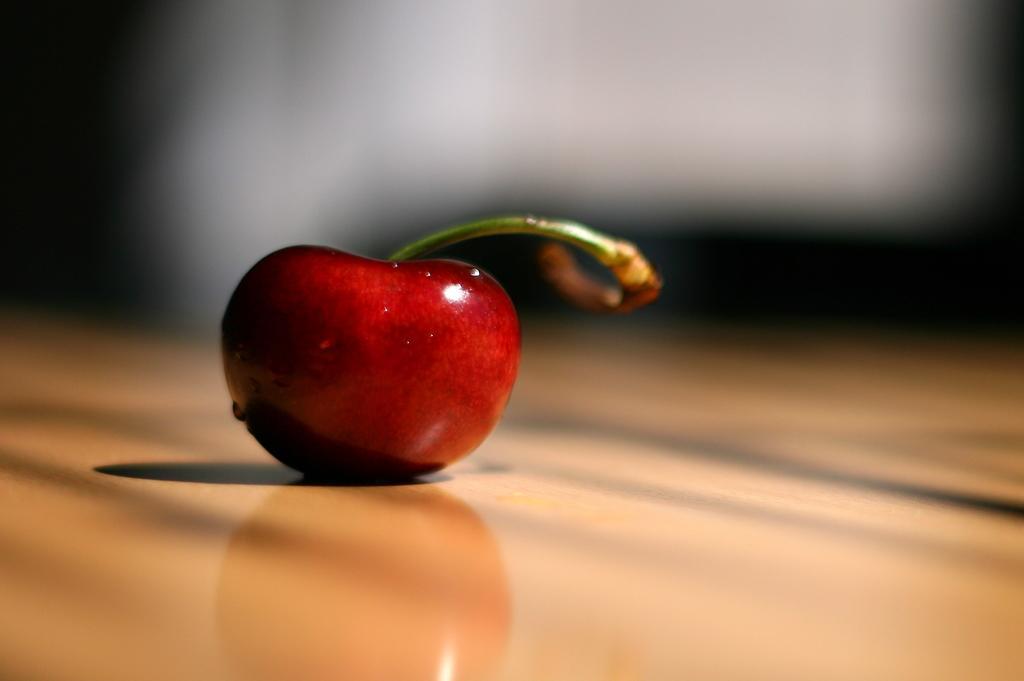Describe this image in one or two sentences. In this image in the front there is a fruit which is red in colour. 